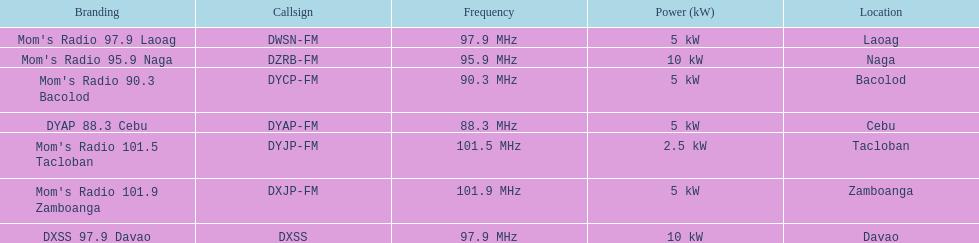How many stations have frequencies exceeding 100 mhz in total? 2. 